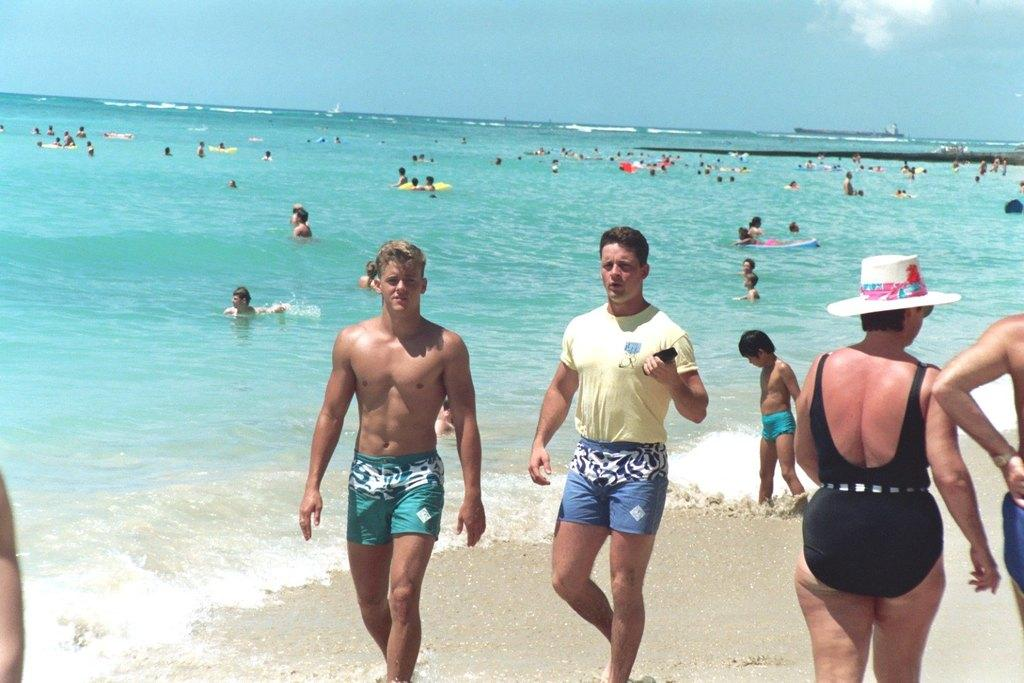What is the main focus of the image? The main focus of the image is the people in the center. What can be seen in the background of the image? There is a big swimming pool in the background of the image. Are there any other people visible in the image? Yes, there are people in the swimming pool. What type of fuel is being used by the organization in the image? There is no organization or fuel mentioned in the image; it features people and a swimming pool. 